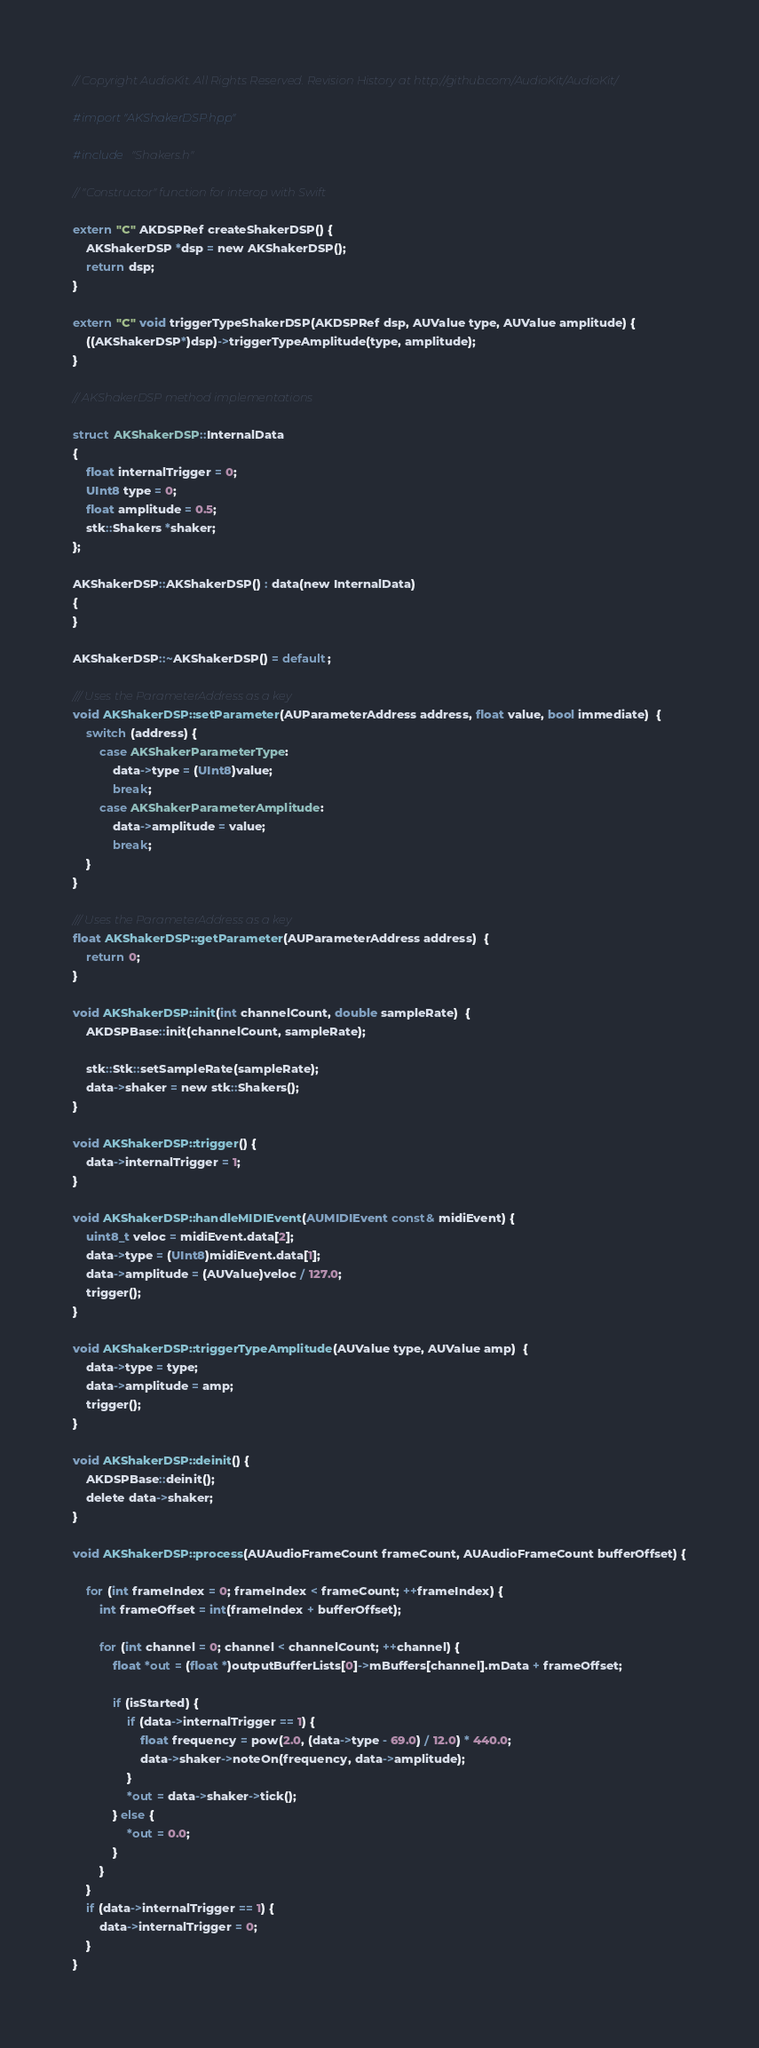Convert code to text. <code><loc_0><loc_0><loc_500><loc_500><_ObjectiveC_>// Copyright AudioKit. All Rights Reserved. Revision History at http://github.com/AudioKit/AudioKit/

#import "AKShakerDSP.hpp"

#include "Shakers.h"

// "Constructor" function for interop with Swift

extern "C" AKDSPRef createShakerDSP() {
    AKShakerDSP *dsp = new AKShakerDSP();
    return dsp;
}

extern "C" void triggerTypeShakerDSP(AKDSPRef dsp, AUValue type, AUValue amplitude) {
    ((AKShakerDSP*)dsp)->triggerTypeAmplitude(type, amplitude);
}

// AKShakerDSP method implementations

struct AKShakerDSP::InternalData
{
    float internalTrigger = 0;
    UInt8 type = 0;
    float amplitude = 0.5;
    stk::Shakers *shaker;
};

AKShakerDSP::AKShakerDSP() : data(new InternalData)
{
}

AKShakerDSP::~AKShakerDSP() = default;

/// Uses the ParameterAddress as a key
void AKShakerDSP::setParameter(AUParameterAddress address, float value, bool immediate)  {
    switch (address) {
        case AKShakerParameterType:
            data->type = (UInt8)value;
            break;
        case AKShakerParameterAmplitude:
            data->amplitude = value;
            break;
    }
}

/// Uses the ParameterAddress as a key
float AKShakerDSP::getParameter(AUParameterAddress address)  {
    return 0;
}

void AKShakerDSP::init(int channelCount, double sampleRate)  {
    AKDSPBase::init(channelCount, sampleRate);

    stk::Stk::setSampleRate(sampleRate);
    data->shaker = new stk::Shakers();
}

void AKShakerDSP::trigger() {
    data->internalTrigger = 1;
}

void AKShakerDSP::handleMIDIEvent(AUMIDIEvent const& midiEvent) {
    uint8_t veloc = midiEvent.data[2];
    data->type = (UInt8)midiEvent.data[1];
    data->amplitude = (AUValue)veloc / 127.0;
    trigger();
}

void AKShakerDSP::triggerTypeAmplitude(AUValue type, AUValue amp)  {
    data->type = type;
    data->amplitude = amp;
    trigger();
}

void AKShakerDSP::deinit() {
    AKDSPBase::deinit();
    delete data->shaker;
}

void AKShakerDSP::process(AUAudioFrameCount frameCount, AUAudioFrameCount bufferOffset) {

    for (int frameIndex = 0; frameIndex < frameCount; ++frameIndex) {
        int frameOffset = int(frameIndex + bufferOffset);

        for (int channel = 0; channel < channelCount; ++channel) {
            float *out = (float *)outputBufferLists[0]->mBuffers[channel].mData + frameOffset;

            if (isStarted) {
                if (data->internalTrigger == 1) {
                    float frequency = pow(2.0, (data->type - 69.0) / 12.0) * 440.0;
                    data->shaker->noteOn(frequency, data->amplitude);
                }
                *out = data->shaker->tick();
            } else {
                *out = 0.0;
            }
        }
    }
    if (data->internalTrigger == 1) {
        data->internalTrigger = 0;
    }
}

</code> 